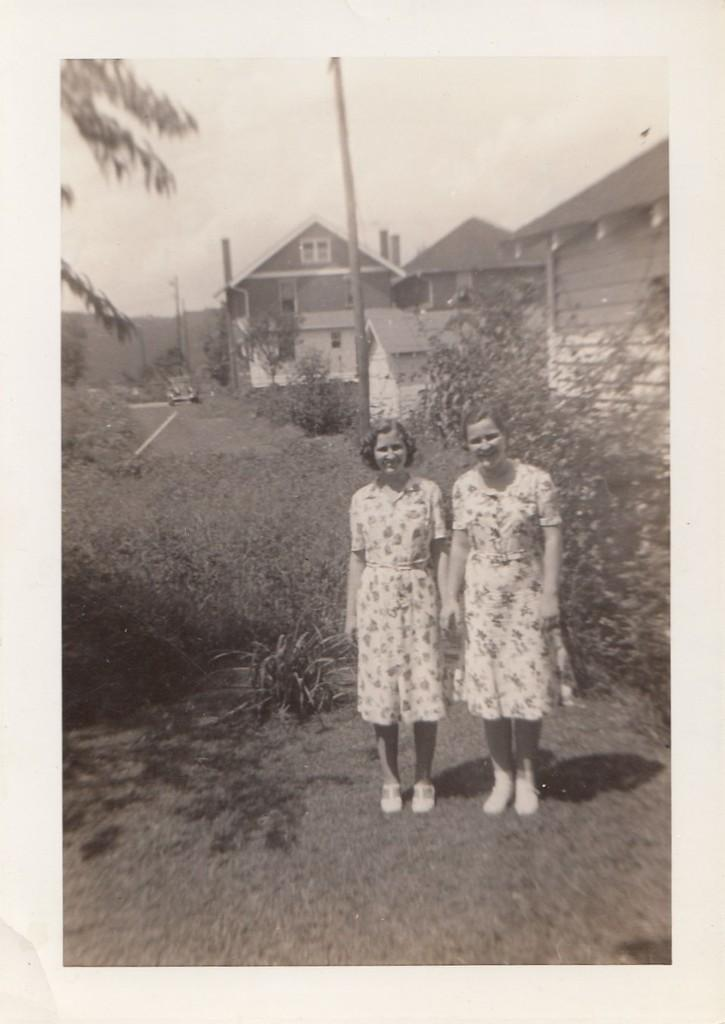What is the color scheme of the image? The image is black and white. How many women are in the image, and what are they doing? There are two women standing and smiling in the image. What type of vegetation can be seen in the image? Bushes and trees are visible in the image. What type of structures are present in the image? There are houses with windows in the image. What other objects can be seen in the image? There are poles in the image. What type of chain can be seen around the women's necks in the image? There is no chain visible around the women's necks in the image. Can you tell me how many toes the women have in the image? The image is in black and white, and it is not possible to determine the number of toes on the women's feet. 